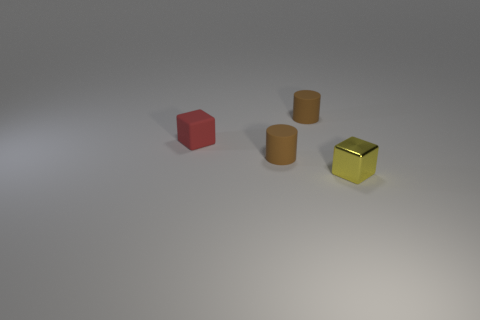There is a thing that is in front of the small matte cube and left of the yellow metallic block; what is its size?
Your response must be concise. Small. Are there more red rubber blocks to the left of the matte block than small yellow metallic objects behind the yellow metal thing?
Your response must be concise. No. What is the color of the tiny metal object?
Your answer should be compact. Yellow. There is a object that is both in front of the matte block and on the left side of the small metal object; what is its color?
Offer a very short reply. Brown. What is the color of the tiny block that is on the left side of the small cube in front of the small cube that is behind the tiny yellow cube?
Offer a terse response. Red. What is the color of the other rubber cube that is the same size as the yellow block?
Keep it short and to the point. Red. The brown thing that is behind the tiny brown rubber thing left of the matte object behind the red rubber cube is what shape?
Keep it short and to the point. Cylinder. How many objects are brown rubber objects or objects that are to the left of the yellow metallic thing?
Provide a succinct answer. 3. There is a brown cylinder in front of the red cube; is its size the same as the small metallic thing?
Make the answer very short. Yes. What is the brown thing that is in front of the tiny red object made of?
Your response must be concise. Rubber. 